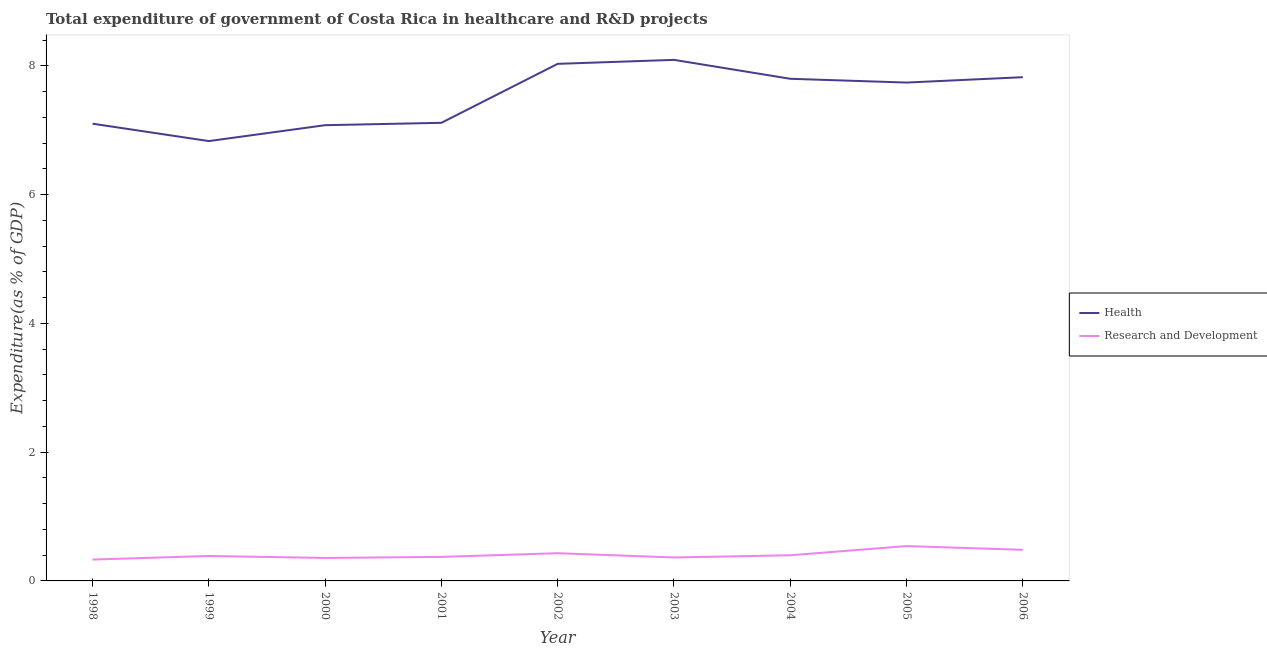How many different coloured lines are there?
Ensure brevity in your answer.  2. What is the expenditure in healthcare in 2000?
Ensure brevity in your answer.  7.08. Across all years, what is the maximum expenditure in healthcare?
Make the answer very short. 8.09. Across all years, what is the minimum expenditure in healthcare?
Your response must be concise. 6.83. In which year was the expenditure in r&d minimum?
Ensure brevity in your answer.  1998. What is the total expenditure in r&d in the graph?
Provide a succinct answer. 3.67. What is the difference between the expenditure in healthcare in 2002 and that in 2005?
Keep it short and to the point. 0.29. What is the difference between the expenditure in healthcare in 1998 and the expenditure in r&d in 2000?
Your answer should be compact. 6.74. What is the average expenditure in r&d per year?
Provide a succinct answer. 0.41. In the year 2006, what is the difference between the expenditure in r&d and expenditure in healthcare?
Provide a succinct answer. -7.34. What is the ratio of the expenditure in r&d in 2002 to that in 2003?
Give a very brief answer. 1.18. Is the expenditure in healthcare in 1998 less than that in 2002?
Provide a short and direct response. Yes. Is the difference between the expenditure in r&d in 2003 and 2006 greater than the difference between the expenditure in healthcare in 2003 and 2006?
Ensure brevity in your answer.  No. What is the difference between the highest and the second highest expenditure in r&d?
Offer a terse response. 0.06. What is the difference between the highest and the lowest expenditure in r&d?
Give a very brief answer. 0.21. Does the expenditure in r&d monotonically increase over the years?
Your answer should be very brief. No. Is the expenditure in r&d strictly less than the expenditure in healthcare over the years?
Make the answer very short. Yes. How many lines are there?
Your answer should be very brief. 2. Where does the legend appear in the graph?
Make the answer very short. Center right. How many legend labels are there?
Your response must be concise. 2. How are the legend labels stacked?
Provide a succinct answer. Vertical. What is the title of the graph?
Your answer should be very brief. Total expenditure of government of Costa Rica in healthcare and R&D projects. What is the label or title of the X-axis?
Offer a very short reply. Year. What is the label or title of the Y-axis?
Ensure brevity in your answer.  Expenditure(as % of GDP). What is the Expenditure(as % of GDP) in Health in 1998?
Provide a succinct answer. 7.1. What is the Expenditure(as % of GDP) in Research and Development in 1998?
Make the answer very short. 0.33. What is the Expenditure(as % of GDP) of Health in 1999?
Make the answer very short. 6.83. What is the Expenditure(as % of GDP) of Research and Development in 1999?
Your response must be concise. 0.39. What is the Expenditure(as % of GDP) in Health in 2000?
Provide a succinct answer. 7.08. What is the Expenditure(as % of GDP) of Research and Development in 2000?
Give a very brief answer. 0.36. What is the Expenditure(as % of GDP) of Health in 2001?
Provide a short and direct response. 7.11. What is the Expenditure(as % of GDP) in Research and Development in 2001?
Ensure brevity in your answer.  0.37. What is the Expenditure(as % of GDP) of Health in 2002?
Ensure brevity in your answer.  8.03. What is the Expenditure(as % of GDP) in Research and Development in 2002?
Your answer should be very brief. 0.43. What is the Expenditure(as % of GDP) in Health in 2003?
Give a very brief answer. 8.09. What is the Expenditure(as % of GDP) of Research and Development in 2003?
Ensure brevity in your answer.  0.36. What is the Expenditure(as % of GDP) in Health in 2004?
Your answer should be compact. 7.8. What is the Expenditure(as % of GDP) in Research and Development in 2004?
Make the answer very short. 0.4. What is the Expenditure(as % of GDP) of Health in 2005?
Your answer should be very brief. 7.74. What is the Expenditure(as % of GDP) in Research and Development in 2005?
Offer a very short reply. 0.54. What is the Expenditure(as % of GDP) of Health in 2006?
Your response must be concise. 7.82. What is the Expenditure(as % of GDP) of Research and Development in 2006?
Your answer should be very brief. 0.48. Across all years, what is the maximum Expenditure(as % of GDP) of Health?
Offer a terse response. 8.09. Across all years, what is the maximum Expenditure(as % of GDP) in Research and Development?
Ensure brevity in your answer.  0.54. Across all years, what is the minimum Expenditure(as % of GDP) in Health?
Provide a succinct answer. 6.83. Across all years, what is the minimum Expenditure(as % of GDP) in Research and Development?
Give a very brief answer. 0.33. What is the total Expenditure(as % of GDP) in Health in the graph?
Your response must be concise. 67.61. What is the total Expenditure(as % of GDP) of Research and Development in the graph?
Make the answer very short. 3.67. What is the difference between the Expenditure(as % of GDP) of Health in 1998 and that in 1999?
Your answer should be very brief. 0.27. What is the difference between the Expenditure(as % of GDP) of Research and Development in 1998 and that in 1999?
Give a very brief answer. -0.06. What is the difference between the Expenditure(as % of GDP) of Health in 1998 and that in 2000?
Make the answer very short. 0.02. What is the difference between the Expenditure(as % of GDP) of Research and Development in 1998 and that in 2000?
Provide a succinct answer. -0.03. What is the difference between the Expenditure(as % of GDP) in Health in 1998 and that in 2001?
Your answer should be very brief. -0.01. What is the difference between the Expenditure(as % of GDP) of Research and Development in 1998 and that in 2001?
Keep it short and to the point. -0.04. What is the difference between the Expenditure(as % of GDP) in Health in 1998 and that in 2002?
Provide a short and direct response. -0.93. What is the difference between the Expenditure(as % of GDP) in Research and Development in 1998 and that in 2002?
Your response must be concise. -0.1. What is the difference between the Expenditure(as % of GDP) of Health in 1998 and that in 2003?
Your response must be concise. -0.99. What is the difference between the Expenditure(as % of GDP) of Research and Development in 1998 and that in 2003?
Your answer should be very brief. -0.03. What is the difference between the Expenditure(as % of GDP) in Health in 1998 and that in 2004?
Ensure brevity in your answer.  -0.7. What is the difference between the Expenditure(as % of GDP) of Research and Development in 1998 and that in 2004?
Offer a very short reply. -0.07. What is the difference between the Expenditure(as % of GDP) in Health in 1998 and that in 2005?
Give a very brief answer. -0.64. What is the difference between the Expenditure(as % of GDP) in Research and Development in 1998 and that in 2005?
Ensure brevity in your answer.  -0.21. What is the difference between the Expenditure(as % of GDP) of Health in 1998 and that in 2006?
Your response must be concise. -0.72. What is the difference between the Expenditure(as % of GDP) in Research and Development in 1998 and that in 2006?
Your answer should be compact. -0.15. What is the difference between the Expenditure(as % of GDP) in Health in 1999 and that in 2000?
Keep it short and to the point. -0.25. What is the difference between the Expenditure(as % of GDP) of Research and Development in 1999 and that in 2000?
Provide a succinct answer. 0.03. What is the difference between the Expenditure(as % of GDP) in Health in 1999 and that in 2001?
Your answer should be very brief. -0.28. What is the difference between the Expenditure(as % of GDP) in Research and Development in 1999 and that in 2001?
Your answer should be compact. 0.01. What is the difference between the Expenditure(as % of GDP) in Health in 1999 and that in 2002?
Offer a terse response. -1.2. What is the difference between the Expenditure(as % of GDP) of Research and Development in 1999 and that in 2002?
Your answer should be compact. -0.04. What is the difference between the Expenditure(as % of GDP) of Health in 1999 and that in 2003?
Keep it short and to the point. -1.26. What is the difference between the Expenditure(as % of GDP) in Research and Development in 1999 and that in 2003?
Your answer should be very brief. 0.02. What is the difference between the Expenditure(as % of GDP) of Health in 1999 and that in 2004?
Provide a short and direct response. -0.97. What is the difference between the Expenditure(as % of GDP) in Research and Development in 1999 and that in 2004?
Keep it short and to the point. -0.01. What is the difference between the Expenditure(as % of GDP) of Health in 1999 and that in 2005?
Give a very brief answer. -0.91. What is the difference between the Expenditure(as % of GDP) of Research and Development in 1999 and that in 2005?
Provide a short and direct response. -0.15. What is the difference between the Expenditure(as % of GDP) in Health in 1999 and that in 2006?
Offer a very short reply. -0.99. What is the difference between the Expenditure(as % of GDP) in Research and Development in 1999 and that in 2006?
Your answer should be very brief. -0.1. What is the difference between the Expenditure(as % of GDP) in Health in 2000 and that in 2001?
Offer a terse response. -0.04. What is the difference between the Expenditure(as % of GDP) in Research and Development in 2000 and that in 2001?
Your answer should be compact. -0.02. What is the difference between the Expenditure(as % of GDP) of Health in 2000 and that in 2002?
Provide a short and direct response. -0.95. What is the difference between the Expenditure(as % of GDP) of Research and Development in 2000 and that in 2002?
Ensure brevity in your answer.  -0.07. What is the difference between the Expenditure(as % of GDP) in Health in 2000 and that in 2003?
Provide a succinct answer. -1.01. What is the difference between the Expenditure(as % of GDP) of Research and Development in 2000 and that in 2003?
Give a very brief answer. -0.01. What is the difference between the Expenditure(as % of GDP) in Health in 2000 and that in 2004?
Give a very brief answer. -0.72. What is the difference between the Expenditure(as % of GDP) of Research and Development in 2000 and that in 2004?
Give a very brief answer. -0.04. What is the difference between the Expenditure(as % of GDP) of Health in 2000 and that in 2005?
Your answer should be very brief. -0.66. What is the difference between the Expenditure(as % of GDP) of Research and Development in 2000 and that in 2005?
Give a very brief answer. -0.18. What is the difference between the Expenditure(as % of GDP) of Health in 2000 and that in 2006?
Make the answer very short. -0.75. What is the difference between the Expenditure(as % of GDP) in Research and Development in 2000 and that in 2006?
Your answer should be very brief. -0.13. What is the difference between the Expenditure(as % of GDP) of Health in 2001 and that in 2002?
Offer a very short reply. -0.92. What is the difference between the Expenditure(as % of GDP) in Research and Development in 2001 and that in 2002?
Provide a short and direct response. -0.06. What is the difference between the Expenditure(as % of GDP) of Health in 2001 and that in 2003?
Offer a very short reply. -0.98. What is the difference between the Expenditure(as % of GDP) in Research and Development in 2001 and that in 2003?
Give a very brief answer. 0.01. What is the difference between the Expenditure(as % of GDP) of Health in 2001 and that in 2004?
Your answer should be very brief. -0.68. What is the difference between the Expenditure(as % of GDP) of Research and Development in 2001 and that in 2004?
Give a very brief answer. -0.03. What is the difference between the Expenditure(as % of GDP) in Health in 2001 and that in 2005?
Provide a succinct answer. -0.62. What is the difference between the Expenditure(as % of GDP) in Research and Development in 2001 and that in 2005?
Give a very brief answer. -0.17. What is the difference between the Expenditure(as % of GDP) in Health in 2001 and that in 2006?
Provide a short and direct response. -0.71. What is the difference between the Expenditure(as % of GDP) in Research and Development in 2001 and that in 2006?
Ensure brevity in your answer.  -0.11. What is the difference between the Expenditure(as % of GDP) of Health in 2002 and that in 2003?
Keep it short and to the point. -0.06. What is the difference between the Expenditure(as % of GDP) in Research and Development in 2002 and that in 2003?
Give a very brief answer. 0.07. What is the difference between the Expenditure(as % of GDP) of Health in 2002 and that in 2004?
Offer a terse response. 0.23. What is the difference between the Expenditure(as % of GDP) of Research and Development in 2002 and that in 2004?
Provide a succinct answer. 0.03. What is the difference between the Expenditure(as % of GDP) of Health in 2002 and that in 2005?
Offer a very short reply. 0.29. What is the difference between the Expenditure(as % of GDP) in Research and Development in 2002 and that in 2005?
Provide a short and direct response. -0.11. What is the difference between the Expenditure(as % of GDP) in Health in 2002 and that in 2006?
Offer a very short reply. 0.21. What is the difference between the Expenditure(as % of GDP) in Research and Development in 2002 and that in 2006?
Your answer should be compact. -0.05. What is the difference between the Expenditure(as % of GDP) in Health in 2003 and that in 2004?
Give a very brief answer. 0.29. What is the difference between the Expenditure(as % of GDP) in Research and Development in 2003 and that in 2004?
Offer a very short reply. -0.03. What is the difference between the Expenditure(as % of GDP) in Health in 2003 and that in 2005?
Offer a very short reply. 0.35. What is the difference between the Expenditure(as % of GDP) in Research and Development in 2003 and that in 2005?
Provide a short and direct response. -0.18. What is the difference between the Expenditure(as % of GDP) in Health in 2003 and that in 2006?
Your answer should be compact. 0.27. What is the difference between the Expenditure(as % of GDP) of Research and Development in 2003 and that in 2006?
Offer a terse response. -0.12. What is the difference between the Expenditure(as % of GDP) of Health in 2004 and that in 2005?
Give a very brief answer. 0.06. What is the difference between the Expenditure(as % of GDP) of Research and Development in 2004 and that in 2005?
Provide a short and direct response. -0.14. What is the difference between the Expenditure(as % of GDP) of Health in 2004 and that in 2006?
Your answer should be very brief. -0.02. What is the difference between the Expenditure(as % of GDP) in Research and Development in 2004 and that in 2006?
Make the answer very short. -0.08. What is the difference between the Expenditure(as % of GDP) in Health in 2005 and that in 2006?
Keep it short and to the point. -0.08. What is the difference between the Expenditure(as % of GDP) of Research and Development in 2005 and that in 2006?
Your answer should be compact. 0.06. What is the difference between the Expenditure(as % of GDP) in Health in 1998 and the Expenditure(as % of GDP) in Research and Development in 1999?
Make the answer very short. 6.71. What is the difference between the Expenditure(as % of GDP) of Health in 1998 and the Expenditure(as % of GDP) of Research and Development in 2000?
Provide a short and direct response. 6.74. What is the difference between the Expenditure(as % of GDP) in Health in 1998 and the Expenditure(as % of GDP) in Research and Development in 2001?
Keep it short and to the point. 6.73. What is the difference between the Expenditure(as % of GDP) in Health in 1998 and the Expenditure(as % of GDP) in Research and Development in 2002?
Your response must be concise. 6.67. What is the difference between the Expenditure(as % of GDP) in Health in 1998 and the Expenditure(as % of GDP) in Research and Development in 2003?
Your answer should be compact. 6.74. What is the difference between the Expenditure(as % of GDP) in Health in 1998 and the Expenditure(as % of GDP) in Research and Development in 2004?
Your response must be concise. 6.7. What is the difference between the Expenditure(as % of GDP) in Health in 1998 and the Expenditure(as % of GDP) in Research and Development in 2005?
Give a very brief answer. 6.56. What is the difference between the Expenditure(as % of GDP) in Health in 1998 and the Expenditure(as % of GDP) in Research and Development in 2006?
Your answer should be compact. 6.62. What is the difference between the Expenditure(as % of GDP) in Health in 1999 and the Expenditure(as % of GDP) in Research and Development in 2000?
Your answer should be very brief. 6.47. What is the difference between the Expenditure(as % of GDP) in Health in 1999 and the Expenditure(as % of GDP) in Research and Development in 2001?
Make the answer very short. 6.46. What is the difference between the Expenditure(as % of GDP) in Health in 1999 and the Expenditure(as % of GDP) in Research and Development in 2002?
Offer a very short reply. 6.4. What is the difference between the Expenditure(as % of GDP) of Health in 1999 and the Expenditure(as % of GDP) of Research and Development in 2003?
Keep it short and to the point. 6.47. What is the difference between the Expenditure(as % of GDP) of Health in 1999 and the Expenditure(as % of GDP) of Research and Development in 2004?
Offer a terse response. 6.43. What is the difference between the Expenditure(as % of GDP) of Health in 1999 and the Expenditure(as % of GDP) of Research and Development in 2005?
Your answer should be compact. 6.29. What is the difference between the Expenditure(as % of GDP) in Health in 1999 and the Expenditure(as % of GDP) in Research and Development in 2006?
Provide a short and direct response. 6.35. What is the difference between the Expenditure(as % of GDP) in Health in 2000 and the Expenditure(as % of GDP) in Research and Development in 2001?
Keep it short and to the point. 6.7. What is the difference between the Expenditure(as % of GDP) of Health in 2000 and the Expenditure(as % of GDP) of Research and Development in 2002?
Make the answer very short. 6.65. What is the difference between the Expenditure(as % of GDP) in Health in 2000 and the Expenditure(as % of GDP) in Research and Development in 2003?
Ensure brevity in your answer.  6.71. What is the difference between the Expenditure(as % of GDP) in Health in 2000 and the Expenditure(as % of GDP) in Research and Development in 2004?
Your answer should be very brief. 6.68. What is the difference between the Expenditure(as % of GDP) of Health in 2000 and the Expenditure(as % of GDP) of Research and Development in 2005?
Ensure brevity in your answer.  6.54. What is the difference between the Expenditure(as % of GDP) of Health in 2000 and the Expenditure(as % of GDP) of Research and Development in 2006?
Your response must be concise. 6.6. What is the difference between the Expenditure(as % of GDP) in Health in 2001 and the Expenditure(as % of GDP) in Research and Development in 2002?
Your answer should be very brief. 6.68. What is the difference between the Expenditure(as % of GDP) in Health in 2001 and the Expenditure(as % of GDP) in Research and Development in 2003?
Make the answer very short. 6.75. What is the difference between the Expenditure(as % of GDP) of Health in 2001 and the Expenditure(as % of GDP) of Research and Development in 2004?
Your answer should be very brief. 6.72. What is the difference between the Expenditure(as % of GDP) of Health in 2001 and the Expenditure(as % of GDP) of Research and Development in 2005?
Your answer should be compact. 6.57. What is the difference between the Expenditure(as % of GDP) in Health in 2001 and the Expenditure(as % of GDP) in Research and Development in 2006?
Your answer should be compact. 6.63. What is the difference between the Expenditure(as % of GDP) in Health in 2002 and the Expenditure(as % of GDP) in Research and Development in 2003?
Offer a terse response. 7.67. What is the difference between the Expenditure(as % of GDP) in Health in 2002 and the Expenditure(as % of GDP) in Research and Development in 2004?
Ensure brevity in your answer.  7.63. What is the difference between the Expenditure(as % of GDP) in Health in 2002 and the Expenditure(as % of GDP) in Research and Development in 2005?
Ensure brevity in your answer.  7.49. What is the difference between the Expenditure(as % of GDP) of Health in 2002 and the Expenditure(as % of GDP) of Research and Development in 2006?
Your answer should be very brief. 7.55. What is the difference between the Expenditure(as % of GDP) in Health in 2003 and the Expenditure(as % of GDP) in Research and Development in 2004?
Your answer should be compact. 7.69. What is the difference between the Expenditure(as % of GDP) in Health in 2003 and the Expenditure(as % of GDP) in Research and Development in 2005?
Ensure brevity in your answer.  7.55. What is the difference between the Expenditure(as % of GDP) in Health in 2003 and the Expenditure(as % of GDP) in Research and Development in 2006?
Ensure brevity in your answer.  7.61. What is the difference between the Expenditure(as % of GDP) in Health in 2004 and the Expenditure(as % of GDP) in Research and Development in 2005?
Ensure brevity in your answer.  7.26. What is the difference between the Expenditure(as % of GDP) of Health in 2004 and the Expenditure(as % of GDP) of Research and Development in 2006?
Make the answer very short. 7.32. What is the difference between the Expenditure(as % of GDP) in Health in 2005 and the Expenditure(as % of GDP) in Research and Development in 2006?
Keep it short and to the point. 7.26. What is the average Expenditure(as % of GDP) in Health per year?
Keep it short and to the point. 7.51. What is the average Expenditure(as % of GDP) in Research and Development per year?
Provide a short and direct response. 0.41. In the year 1998, what is the difference between the Expenditure(as % of GDP) in Health and Expenditure(as % of GDP) in Research and Development?
Your answer should be very brief. 6.77. In the year 1999, what is the difference between the Expenditure(as % of GDP) of Health and Expenditure(as % of GDP) of Research and Development?
Your answer should be compact. 6.44. In the year 2000, what is the difference between the Expenditure(as % of GDP) of Health and Expenditure(as % of GDP) of Research and Development?
Offer a terse response. 6.72. In the year 2001, what is the difference between the Expenditure(as % of GDP) in Health and Expenditure(as % of GDP) in Research and Development?
Offer a very short reply. 6.74. In the year 2002, what is the difference between the Expenditure(as % of GDP) in Health and Expenditure(as % of GDP) in Research and Development?
Provide a succinct answer. 7.6. In the year 2003, what is the difference between the Expenditure(as % of GDP) in Health and Expenditure(as % of GDP) in Research and Development?
Keep it short and to the point. 7.73. In the year 2004, what is the difference between the Expenditure(as % of GDP) of Health and Expenditure(as % of GDP) of Research and Development?
Offer a very short reply. 7.4. In the year 2005, what is the difference between the Expenditure(as % of GDP) of Health and Expenditure(as % of GDP) of Research and Development?
Your response must be concise. 7.2. In the year 2006, what is the difference between the Expenditure(as % of GDP) of Health and Expenditure(as % of GDP) of Research and Development?
Your response must be concise. 7.34. What is the ratio of the Expenditure(as % of GDP) of Health in 1998 to that in 1999?
Offer a very short reply. 1.04. What is the ratio of the Expenditure(as % of GDP) in Research and Development in 1998 to that in 1999?
Ensure brevity in your answer.  0.86. What is the ratio of the Expenditure(as % of GDP) in Research and Development in 1998 to that in 2000?
Your answer should be very brief. 0.93. What is the ratio of the Expenditure(as % of GDP) in Health in 1998 to that in 2001?
Offer a terse response. 1. What is the ratio of the Expenditure(as % of GDP) in Research and Development in 1998 to that in 2001?
Your response must be concise. 0.89. What is the ratio of the Expenditure(as % of GDP) in Health in 1998 to that in 2002?
Offer a terse response. 0.88. What is the ratio of the Expenditure(as % of GDP) of Research and Development in 1998 to that in 2002?
Give a very brief answer. 0.77. What is the ratio of the Expenditure(as % of GDP) in Health in 1998 to that in 2003?
Provide a short and direct response. 0.88. What is the ratio of the Expenditure(as % of GDP) in Research and Development in 1998 to that in 2003?
Your answer should be compact. 0.91. What is the ratio of the Expenditure(as % of GDP) in Health in 1998 to that in 2004?
Provide a succinct answer. 0.91. What is the ratio of the Expenditure(as % of GDP) in Research and Development in 1998 to that in 2004?
Provide a succinct answer. 0.83. What is the ratio of the Expenditure(as % of GDP) of Health in 1998 to that in 2005?
Your response must be concise. 0.92. What is the ratio of the Expenditure(as % of GDP) of Research and Development in 1998 to that in 2005?
Ensure brevity in your answer.  0.61. What is the ratio of the Expenditure(as % of GDP) in Health in 1998 to that in 2006?
Ensure brevity in your answer.  0.91. What is the ratio of the Expenditure(as % of GDP) of Research and Development in 1998 to that in 2006?
Your answer should be compact. 0.69. What is the ratio of the Expenditure(as % of GDP) of Health in 1999 to that in 2000?
Provide a succinct answer. 0.97. What is the ratio of the Expenditure(as % of GDP) of Research and Development in 1999 to that in 2000?
Keep it short and to the point. 1.09. What is the ratio of the Expenditure(as % of GDP) of Health in 1999 to that in 2001?
Make the answer very short. 0.96. What is the ratio of the Expenditure(as % of GDP) in Research and Development in 1999 to that in 2001?
Offer a terse response. 1.04. What is the ratio of the Expenditure(as % of GDP) of Health in 1999 to that in 2002?
Provide a succinct answer. 0.85. What is the ratio of the Expenditure(as % of GDP) in Research and Development in 1999 to that in 2002?
Your answer should be compact. 0.9. What is the ratio of the Expenditure(as % of GDP) in Health in 1999 to that in 2003?
Your answer should be very brief. 0.84. What is the ratio of the Expenditure(as % of GDP) of Research and Development in 1999 to that in 2003?
Ensure brevity in your answer.  1.06. What is the ratio of the Expenditure(as % of GDP) in Health in 1999 to that in 2004?
Your response must be concise. 0.88. What is the ratio of the Expenditure(as % of GDP) in Research and Development in 1999 to that in 2004?
Give a very brief answer. 0.97. What is the ratio of the Expenditure(as % of GDP) of Health in 1999 to that in 2005?
Your answer should be very brief. 0.88. What is the ratio of the Expenditure(as % of GDP) in Research and Development in 1999 to that in 2005?
Provide a short and direct response. 0.72. What is the ratio of the Expenditure(as % of GDP) in Health in 1999 to that in 2006?
Your response must be concise. 0.87. What is the ratio of the Expenditure(as % of GDP) in Research and Development in 1999 to that in 2006?
Your answer should be very brief. 0.8. What is the ratio of the Expenditure(as % of GDP) of Health in 2000 to that in 2001?
Make the answer very short. 0.99. What is the ratio of the Expenditure(as % of GDP) of Research and Development in 2000 to that in 2001?
Your response must be concise. 0.96. What is the ratio of the Expenditure(as % of GDP) in Health in 2000 to that in 2002?
Your response must be concise. 0.88. What is the ratio of the Expenditure(as % of GDP) in Research and Development in 2000 to that in 2002?
Your response must be concise. 0.83. What is the ratio of the Expenditure(as % of GDP) in Health in 2000 to that in 2003?
Give a very brief answer. 0.87. What is the ratio of the Expenditure(as % of GDP) in Research and Development in 2000 to that in 2003?
Keep it short and to the point. 0.98. What is the ratio of the Expenditure(as % of GDP) of Health in 2000 to that in 2004?
Provide a succinct answer. 0.91. What is the ratio of the Expenditure(as % of GDP) in Research and Development in 2000 to that in 2004?
Your response must be concise. 0.9. What is the ratio of the Expenditure(as % of GDP) of Health in 2000 to that in 2005?
Your answer should be compact. 0.91. What is the ratio of the Expenditure(as % of GDP) of Research and Development in 2000 to that in 2005?
Your answer should be very brief. 0.66. What is the ratio of the Expenditure(as % of GDP) in Health in 2000 to that in 2006?
Give a very brief answer. 0.9. What is the ratio of the Expenditure(as % of GDP) of Research and Development in 2000 to that in 2006?
Ensure brevity in your answer.  0.74. What is the ratio of the Expenditure(as % of GDP) of Health in 2001 to that in 2002?
Make the answer very short. 0.89. What is the ratio of the Expenditure(as % of GDP) of Research and Development in 2001 to that in 2002?
Offer a terse response. 0.87. What is the ratio of the Expenditure(as % of GDP) of Health in 2001 to that in 2003?
Ensure brevity in your answer.  0.88. What is the ratio of the Expenditure(as % of GDP) in Research and Development in 2001 to that in 2003?
Give a very brief answer. 1.02. What is the ratio of the Expenditure(as % of GDP) in Health in 2001 to that in 2004?
Make the answer very short. 0.91. What is the ratio of the Expenditure(as % of GDP) in Research and Development in 2001 to that in 2004?
Offer a terse response. 0.94. What is the ratio of the Expenditure(as % of GDP) in Health in 2001 to that in 2005?
Provide a short and direct response. 0.92. What is the ratio of the Expenditure(as % of GDP) of Research and Development in 2001 to that in 2005?
Your answer should be very brief. 0.69. What is the ratio of the Expenditure(as % of GDP) of Health in 2001 to that in 2006?
Give a very brief answer. 0.91. What is the ratio of the Expenditure(as % of GDP) in Research and Development in 2001 to that in 2006?
Provide a succinct answer. 0.77. What is the ratio of the Expenditure(as % of GDP) of Research and Development in 2002 to that in 2003?
Your response must be concise. 1.18. What is the ratio of the Expenditure(as % of GDP) of Health in 2002 to that in 2004?
Offer a terse response. 1.03. What is the ratio of the Expenditure(as % of GDP) of Research and Development in 2002 to that in 2004?
Ensure brevity in your answer.  1.08. What is the ratio of the Expenditure(as % of GDP) in Health in 2002 to that in 2005?
Your answer should be compact. 1.04. What is the ratio of the Expenditure(as % of GDP) in Research and Development in 2002 to that in 2005?
Give a very brief answer. 0.8. What is the ratio of the Expenditure(as % of GDP) of Health in 2002 to that in 2006?
Provide a short and direct response. 1.03. What is the ratio of the Expenditure(as % of GDP) of Research and Development in 2002 to that in 2006?
Your answer should be very brief. 0.89. What is the ratio of the Expenditure(as % of GDP) of Health in 2003 to that in 2004?
Offer a terse response. 1.04. What is the ratio of the Expenditure(as % of GDP) in Research and Development in 2003 to that in 2004?
Offer a very short reply. 0.91. What is the ratio of the Expenditure(as % of GDP) of Health in 2003 to that in 2005?
Your answer should be compact. 1.05. What is the ratio of the Expenditure(as % of GDP) of Research and Development in 2003 to that in 2005?
Your response must be concise. 0.67. What is the ratio of the Expenditure(as % of GDP) in Health in 2003 to that in 2006?
Offer a very short reply. 1.03. What is the ratio of the Expenditure(as % of GDP) in Research and Development in 2003 to that in 2006?
Provide a short and direct response. 0.75. What is the ratio of the Expenditure(as % of GDP) of Health in 2004 to that in 2005?
Offer a very short reply. 1.01. What is the ratio of the Expenditure(as % of GDP) of Research and Development in 2004 to that in 2005?
Keep it short and to the point. 0.74. What is the ratio of the Expenditure(as % of GDP) in Research and Development in 2004 to that in 2006?
Ensure brevity in your answer.  0.83. What is the ratio of the Expenditure(as % of GDP) of Health in 2005 to that in 2006?
Provide a succinct answer. 0.99. What is the ratio of the Expenditure(as % of GDP) in Research and Development in 2005 to that in 2006?
Keep it short and to the point. 1.12. What is the difference between the highest and the second highest Expenditure(as % of GDP) in Health?
Ensure brevity in your answer.  0.06. What is the difference between the highest and the second highest Expenditure(as % of GDP) in Research and Development?
Make the answer very short. 0.06. What is the difference between the highest and the lowest Expenditure(as % of GDP) of Health?
Keep it short and to the point. 1.26. What is the difference between the highest and the lowest Expenditure(as % of GDP) of Research and Development?
Keep it short and to the point. 0.21. 